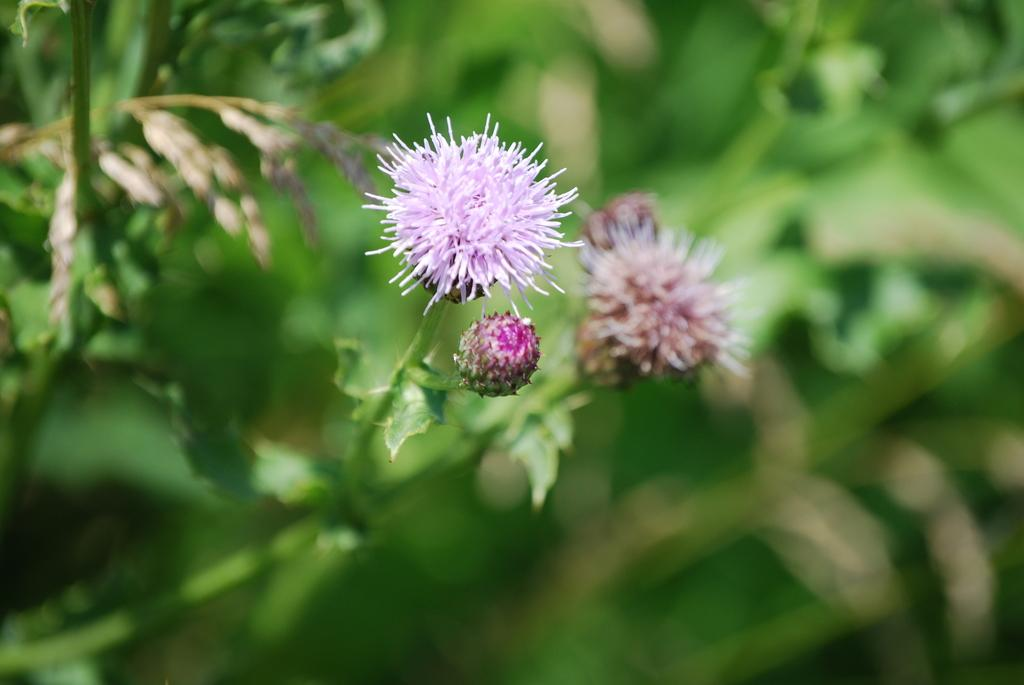What type of plant is visible in the image? The plant in the image has flowers and buds. Can you describe the flowers on the plant? The flowers on the plant are visible in the image. What is the condition of the background in the image? The background of the image is blurred. How many fish can be seen swimming in the image? There are no fish present in the image. In which direction does the plant face in the image? The image does not provide information about the direction the plant is facing. 